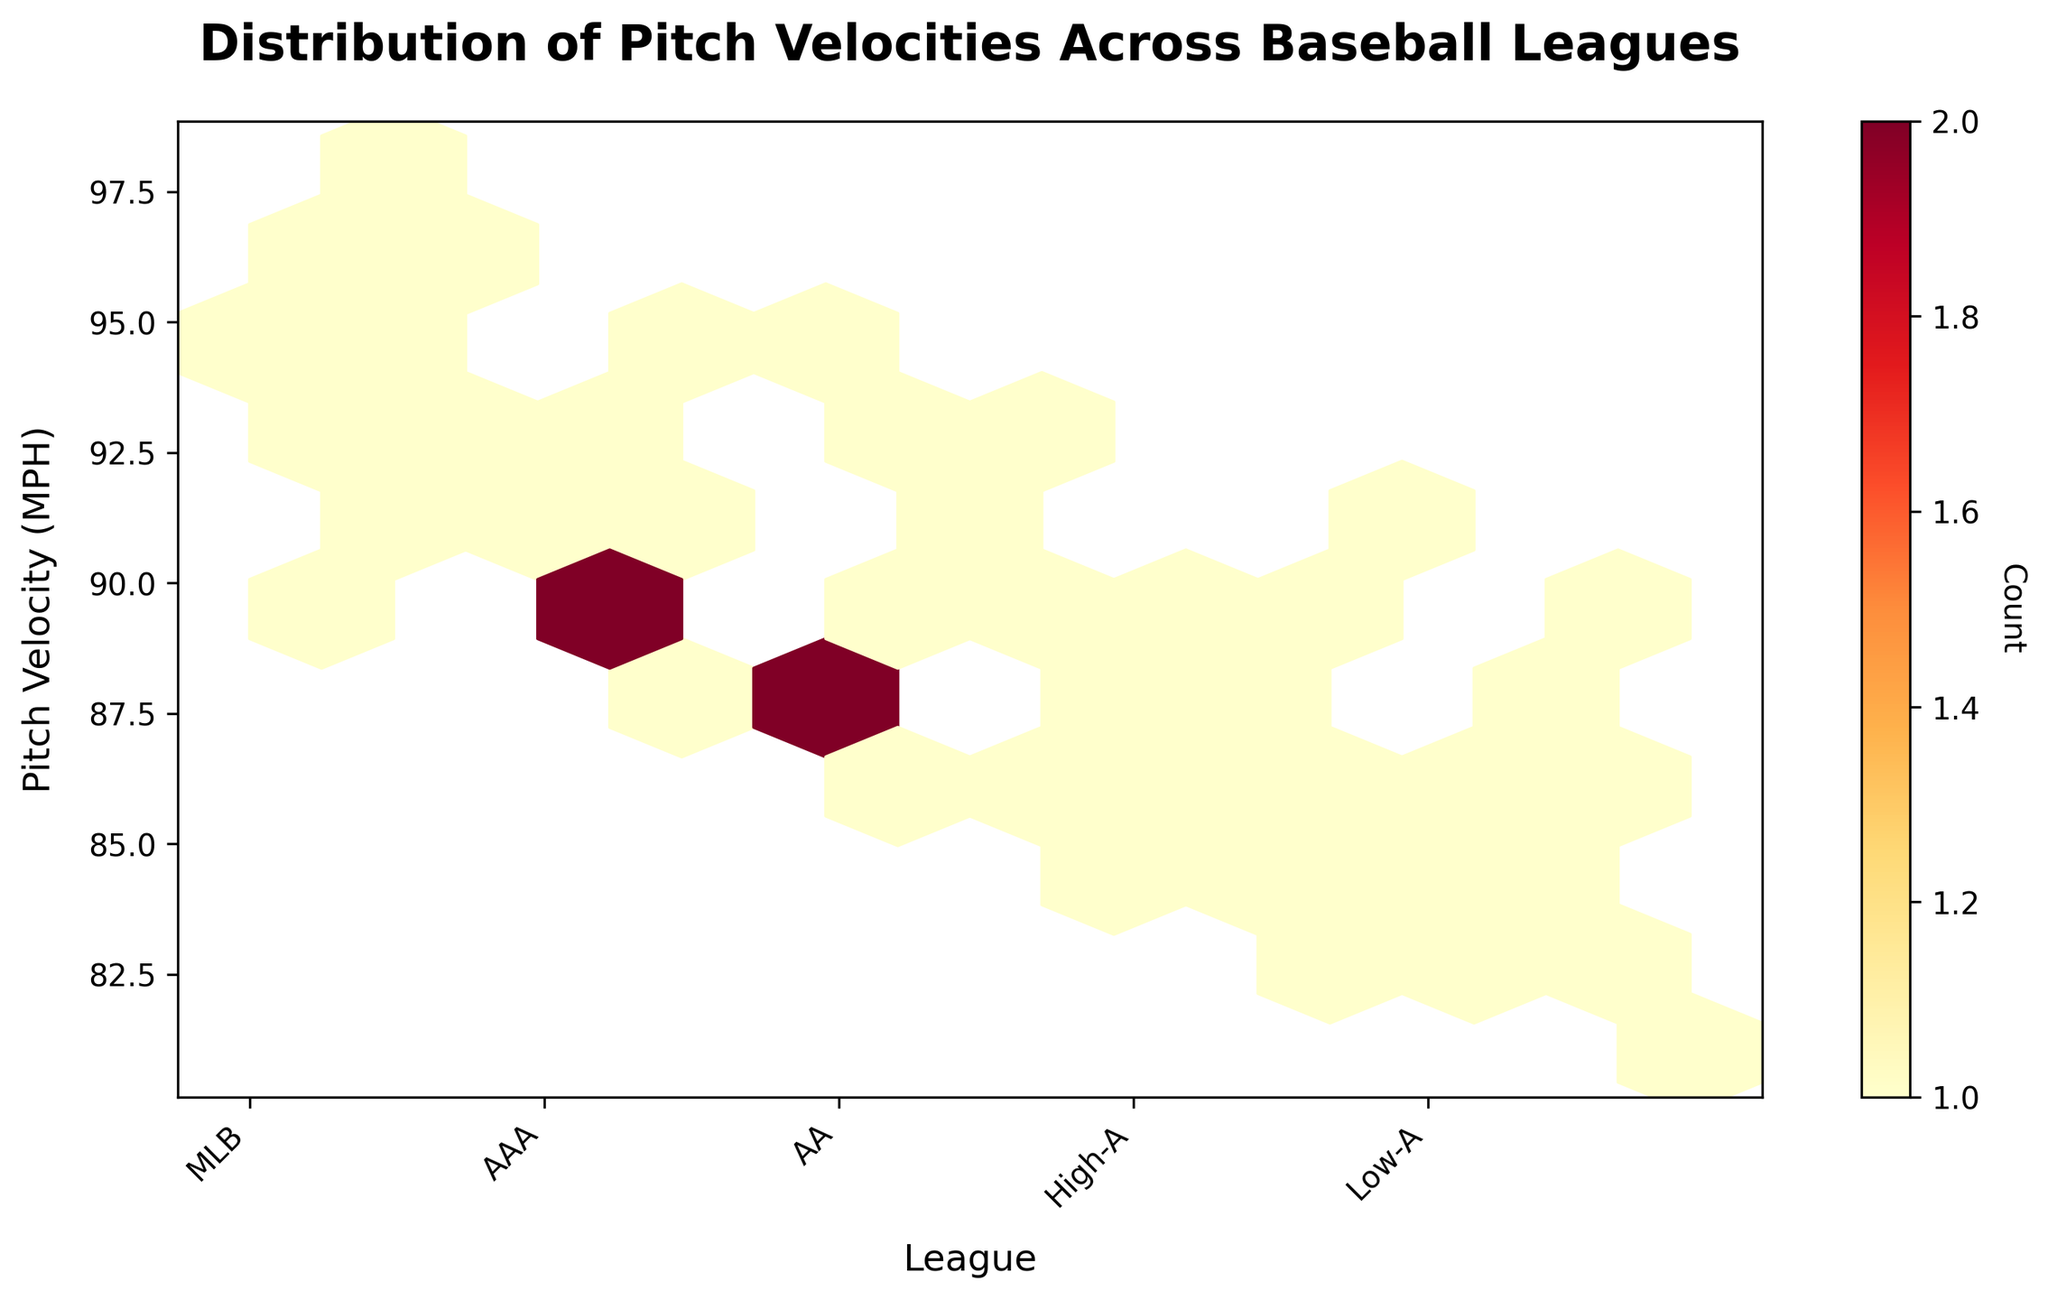What is the title of the hexbin plot? The title of the plot is typically displayed at the top and summarizes what the plot is about. In this case, it should mention the distribution of pitch velocities across baseball leagues.
Answer: Distribution of Pitch Velocities Across Baseball Leagues Which league has the highest range of pitch velocities? To determine the league with the highest range, observe the vertical spread of data points across the different leagues. The widest range will have the data points spread over a greater vertical distance.
Answer: MLB What does the color in the hexbin plot indicate? In hexbin plots, color usually represents the count or density of data points in a region. The color bar indicates this information. Here, areas with more data points are shown in warmer colors.
Answer: Count Which league has the most dense concentration of pitch velocities? To find the densest concentration, look at where the hexagons are darkest or have the warmest colors, indicating higher counts of data points.
Answer: MLB How do pitch velocities compare between Low-A and High-A leagues? By comparing the vertical spread and density of hexagons, you can see that Low-A has lower pitch velocities and a slightly narrower range compared to High-A.
Answer: Lower and narrower range in Low-A What is the approximate median pitch velocity across all leagues? The median pitch velocity is the value that divides the dataset into two equal halves. Observing the central tendency across all leagues, the midpoint is around the value where data is most concentrated.
Answer: ~90 MPH Which league has the lowest maximum pitch velocity? To find this, look at the highest point on the vertical axis for each league and identify which one is the lowest.
Answer: Low-A What is the distribution spread of pitch velocities in the AA league? The spread can be determined by observing the vertical range of the hexagons for AA. The velocities range from approximately 85 MPH to 93 MPH.
Answer: 85-93 MPH Compare the average pitch velocities between the MLB and AA leagues. The average can be approximated by identifying the central tendencies of the data points in each league. MLB data points are generally higher in pitch velocity compared to AA.
Answer: Higher in MLB Which leagues have overlapping pitch velocity ranges? Observing the vertical ranges for each league, note where they overlap. Both AAA and AA overlap within the velocity range of roughly 87 to 95 MPH.
Answer: AAA and AA 